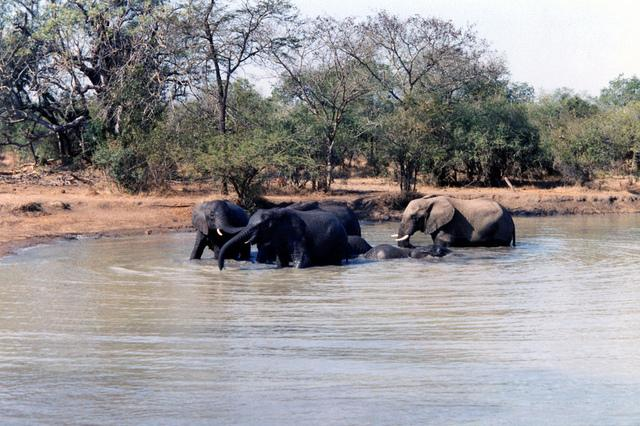What do the animals all have?

Choices:
A) stingers
B) tusks
C) wings
D) gills tusks 